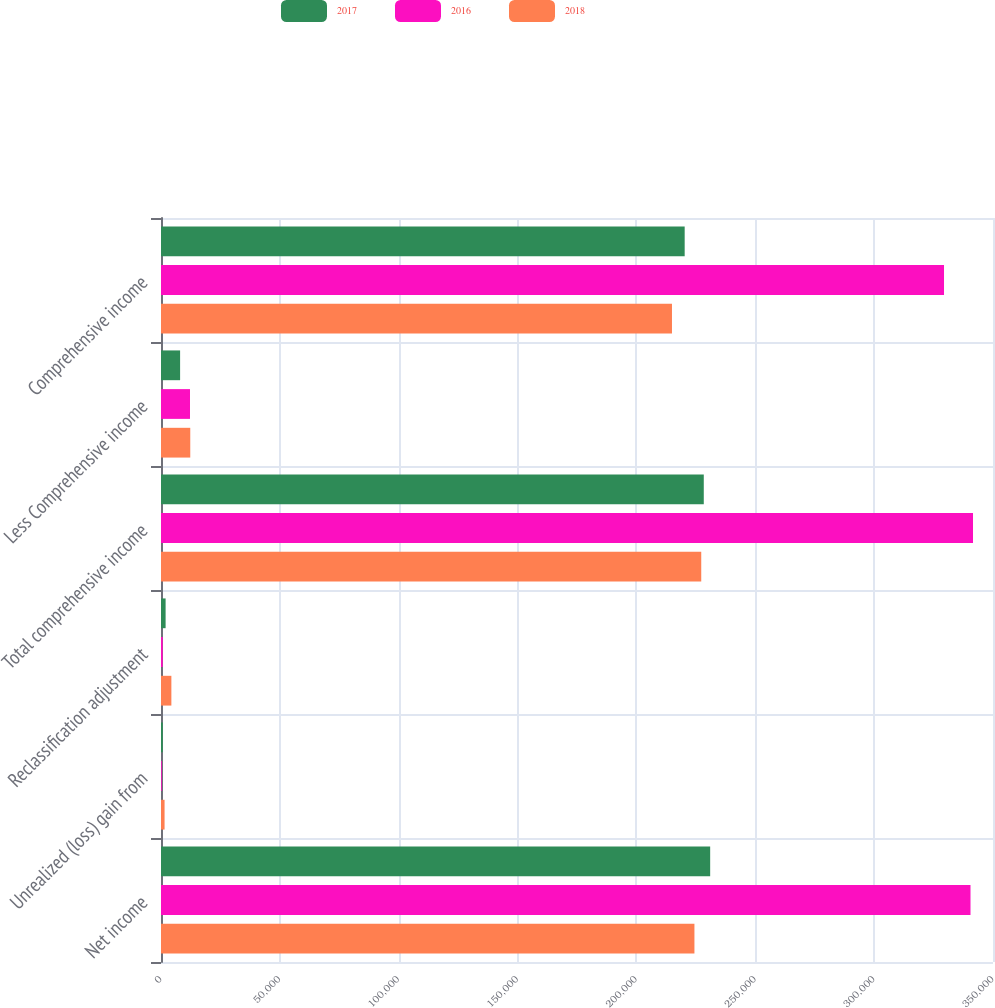Convert chart. <chart><loc_0><loc_0><loc_500><loc_500><stacked_bar_chart><ecel><fcel>Net income<fcel>Unrealized (loss) gain from<fcel>Reclassification adjustment<fcel>Total comprehensive income<fcel>Less Comprehensive income<fcel>Comprehensive income<nl><fcel>2017<fcel>231022<fcel>751<fcel>1938<fcel>228333<fcel>8036<fcel>220297<nl><fcel>2016<fcel>340536<fcel>319<fcel>730<fcel>341585<fcel>12193<fcel>329392<nl><fcel>2018<fcel>224402<fcel>1500<fcel>4364<fcel>227266<fcel>12311<fcel>214955<nl></chart> 